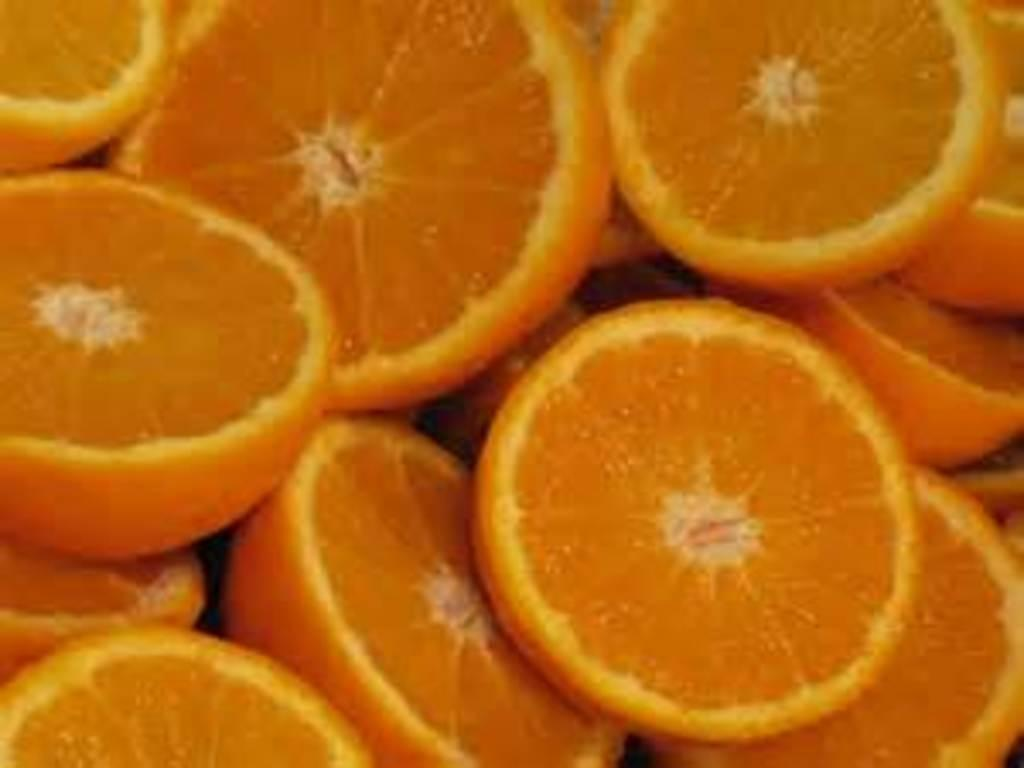What type of fruit is featured in the image? There is a group of sliced oranges in the image. How are the oranges presented in the image? The oranges are sliced in the image. What scent can be detected from the peace symbol in the image? There is no peace symbol present in the image, and therefore no scent can be detected from it. 